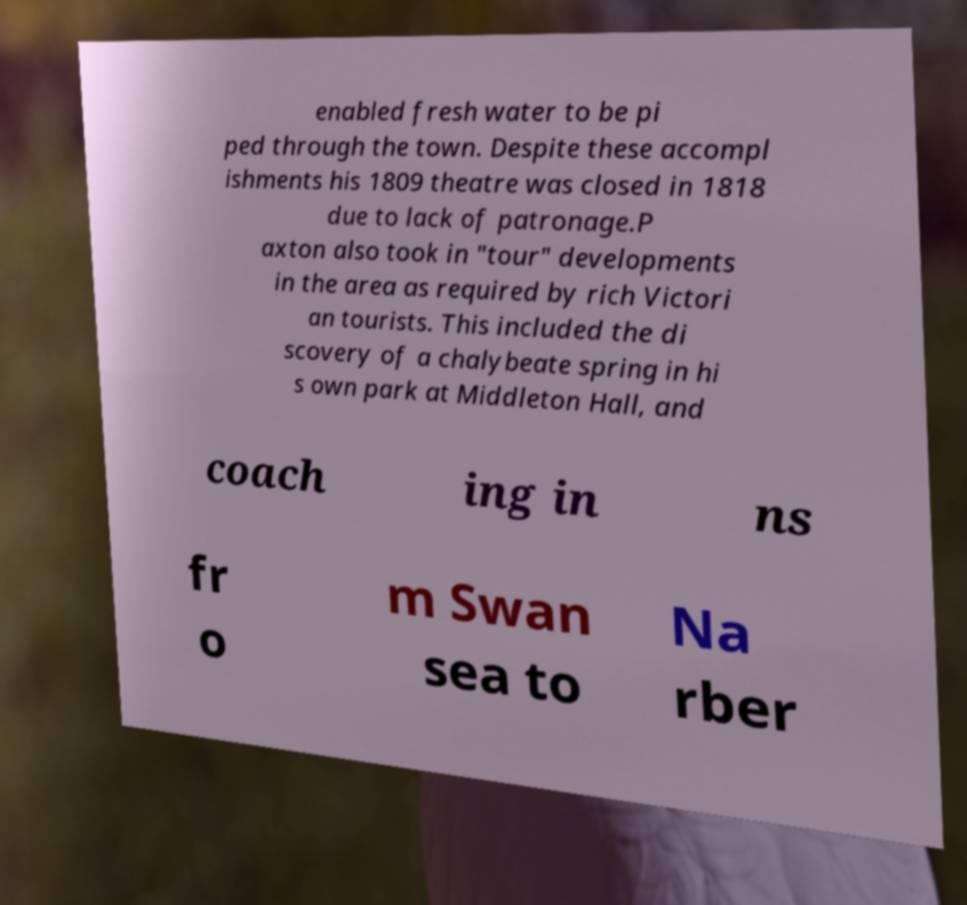Can you read and provide the text displayed in the image?This photo seems to have some interesting text. Can you extract and type it out for me? enabled fresh water to be pi ped through the town. Despite these accompl ishments his 1809 theatre was closed in 1818 due to lack of patronage.P axton also took in "tour" developments in the area as required by rich Victori an tourists. This included the di scovery of a chalybeate spring in hi s own park at Middleton Hall, and coach ing in ns fr o m Swan sea to Na rber 